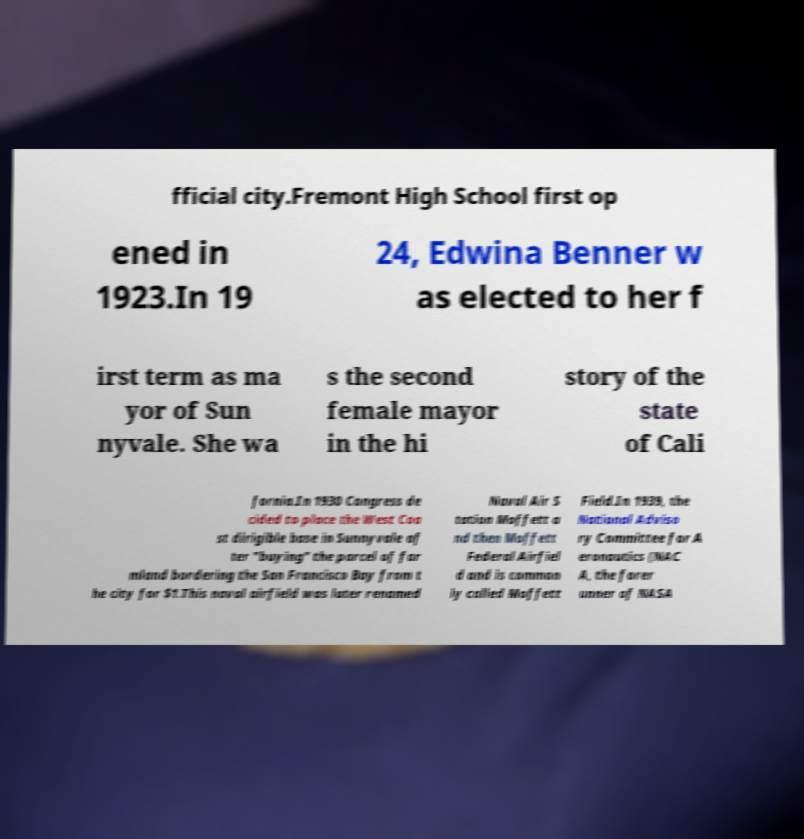Could you assist in decoding the text presented in this image and type it out clearly? fficial city.Fremont High School first op ened in 1923.In 19 24, Edwina Benner w as elected to her f irst term as ma yor of Sun nyvale. She wa s the second female mayor in the hi story of the state of Cali fornia.In 1930 Congress de cided to place the West Coa st dirigible base in Sunnyvale af ter "buying" the parcel of far mland bordering the San Francisco Bay from t he city for $1.This naval airfield was later renamed Naval Air S tation Moffett a nd then Moffett Federal Airfiel d and is common ly called Moffett Field.In 1939, the National Adviso ry Committee for A eronautics (NAC A, the forer unner of NASA 